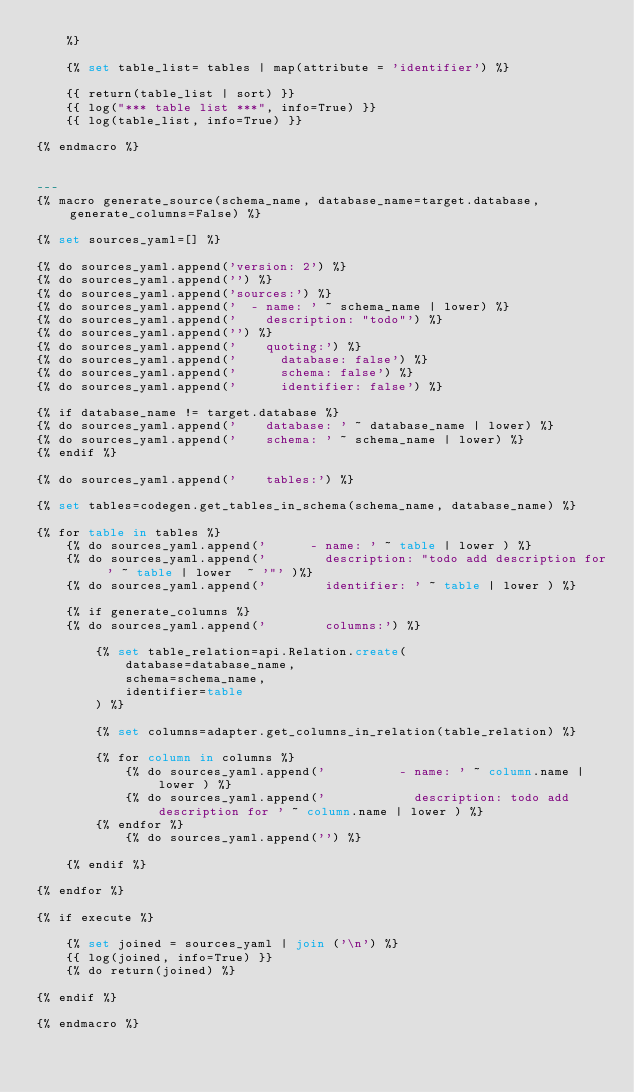Convert code to text. <code><loc_0><loc_0><loc_500><loc_500><_SQL_>    %}

    {% set table_list= tables | map(attribute = 'identifier') %}

    {{ return(table_list | sort) }}
    {{ log("*** table list ***", info=True) }}
    {{ log(table_list, info=True) }}

{% endmacro %}


---
{% macro generate_source(schema_name, database_name=target.database, generate_columns=False) %}

{% set sources_yaml=[] %}

{% do sources_yaml.append('version: 2') %}
{% do sources_yaml.append('') %}
{% do sources_yaml.append('sources:') %}
{% do sources_yaml.append('  - name: ' ~ schema_name | lower) %}
{% do sources_yaml.append('    description: "todo"') %}
{% do sources_yaml.append('') %}
{% do sources_yaml.append('    quoting:') %}
{% do sources_yaml.append('      database: false') %}
{% do sources_yaml.append('      schema: false') %}
{% do sources_yaml.append('      identifier: false') %}

{% if database_name != target.database %}
{% do sources_yaml.append('    database: ' ~ database_name | lower) %}
{% do sources_yaml.append('    schema: ' ~ schema_name | lower) %}
{% endif %}

{% do sources_yaml.append('    tables:') %}

{% set tables=codegen.get_tables_in_schema(schema_name, database_name) %}

{% for table in tables %}
    {% do sources_yaml.append('      - name: ' ~ table | lower ) %}
    {% do sources_yaml.append('        description: "todo add description for ' ~ table | lower  ~ '"' )%}
    {% do sources_yaml.append('        identifier: ' ~ table | lower ) %}

    {% if generate_columns %}
    {% do sources_yaml.append('        columns:') %}

        {% set table_relation=api.Relation.create(
            database=database_name,
            schema=schema_name,
            identifier=table
        ) %}

        {% set columns=adapter.get_columns_in_relation(table_relation) %}

        {% for column in columns %}
            {% do sources_yaml.append('          - name: ' ~ column.name | lower ) %}
            {% do sources_yaml.append('            description: todo add description for ' ~ column.name | lower ) %}
        {% endfor %}
            {% do sources_yaml.append('') %}

    {% endif %}

{% endfor %}

{% if execute %}

    {% set joined = sources_yaml | join ('\n') %}
    {{ log(joined, info=True) }}
    {% do return(joined) %}

{% endif %}

{% endmacro %}
</code> 